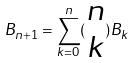<formula> <loc_0><loc_0><loc_500><loc_500>B _ { n + 1 } = \sum _ { k = 0 } ^ { n } ( \begin{matrix} n \\ k \end{matrix} ) B _ { k }</formula> 